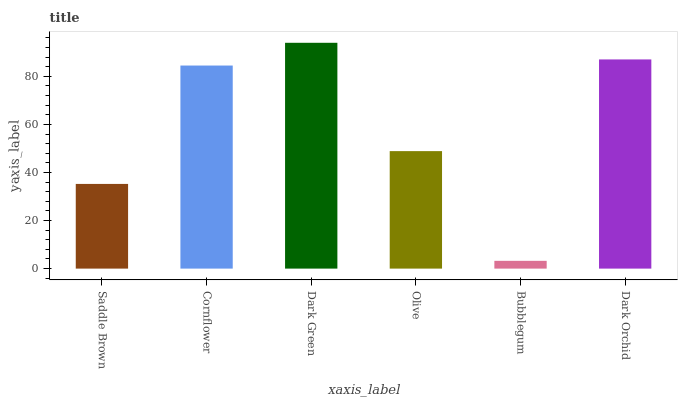Is Bubblegum the minimum?
Answer yes or no. Yes. Is Dark Green the maximum?
Answer yes or no. Yes. Is Cornflower the minimum?
Answer yes or no. No. Is Cornflower the maximum?
Answer yes or no. No. Is Cornflower greater than Saddle Brown?
Answer yes or no. Yes. Is Saddle Brown less than Cornflower?
Answer yes or no. Yes. Is Saddle Brown greater than Cornflower?
Answer yes or no. No. Is Cornflower less than Saddle Brown?
Answer yes or no. No. Is Cornflower the high median?
Answer yes or no. Yes. Is Olive the low median?
Answer yes or no. Yes. Is Dark Orchid the high median?
Answer yes or no. No. Is Dark Orchid the low median?
Answer yes or no. No. 